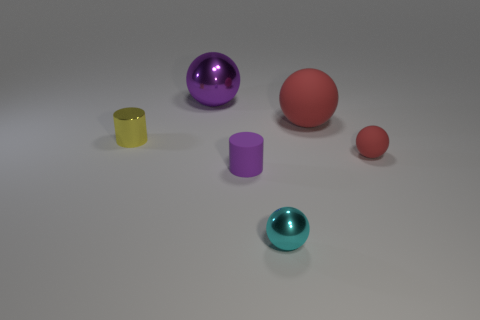Are there any tiny cylinders that are right of the sphere left of the rubber thing that is on the left side of the large red rubber thing? yes 